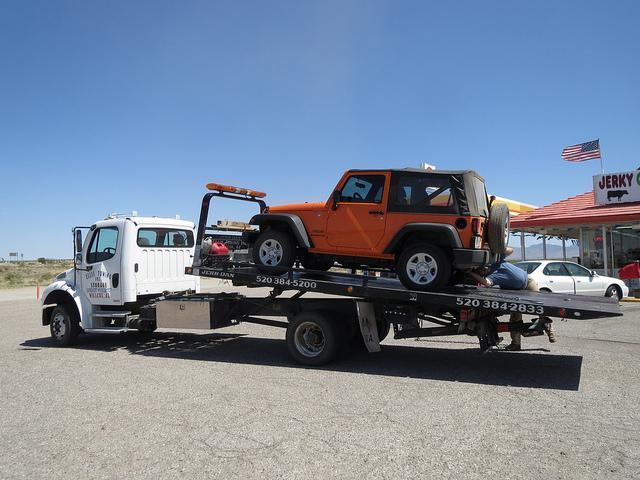How many wheels on the truck?
Give a very brief answer. 4. How many cars can be seen?
Give a very brief answer. 2. 